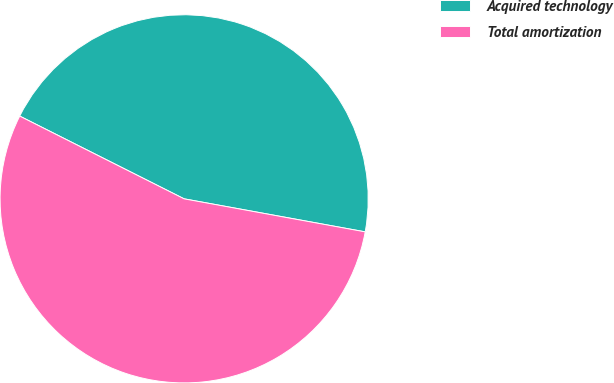<chart> <loc_0><loc_0><loc_500><loc_500><pie_chart><fcel>Acquired technology<fcel>Total amortization<nl><fcel>45.45%<fcel>54.55%<nl></chart> 